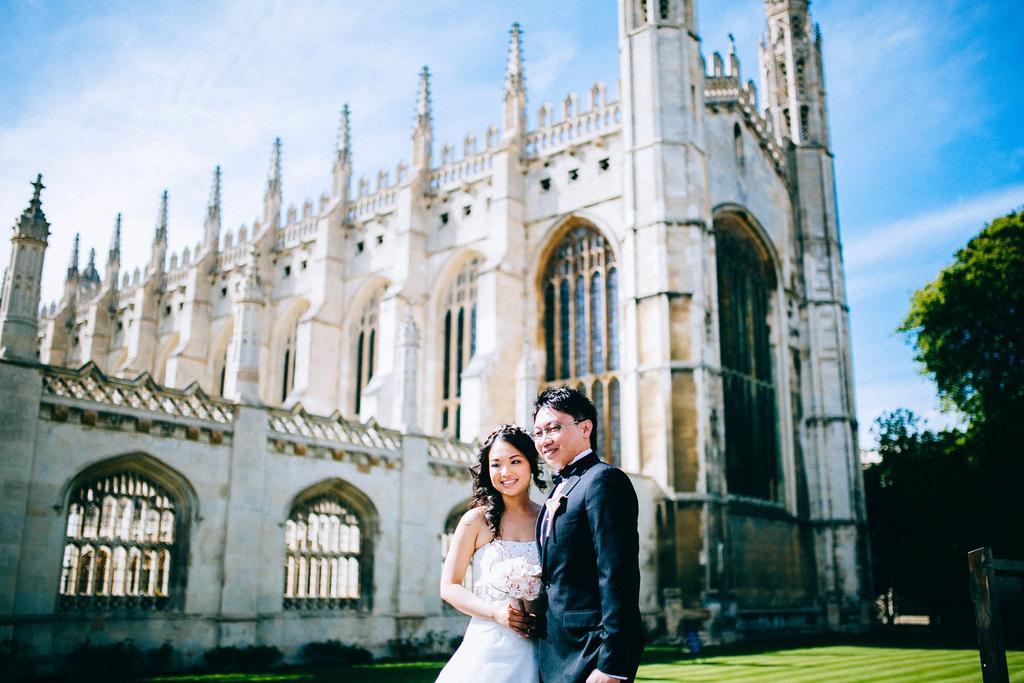In one or two sentences, can you explain what this image depicts? This is an outside view. At the bottom there is a man and a woman are standing facing towards the left side and smiling. On the ground, I can see the grass. In the background there is a building and trees. In the bottom right-hand corner there is an object. At the top of the image I can see the sky. 